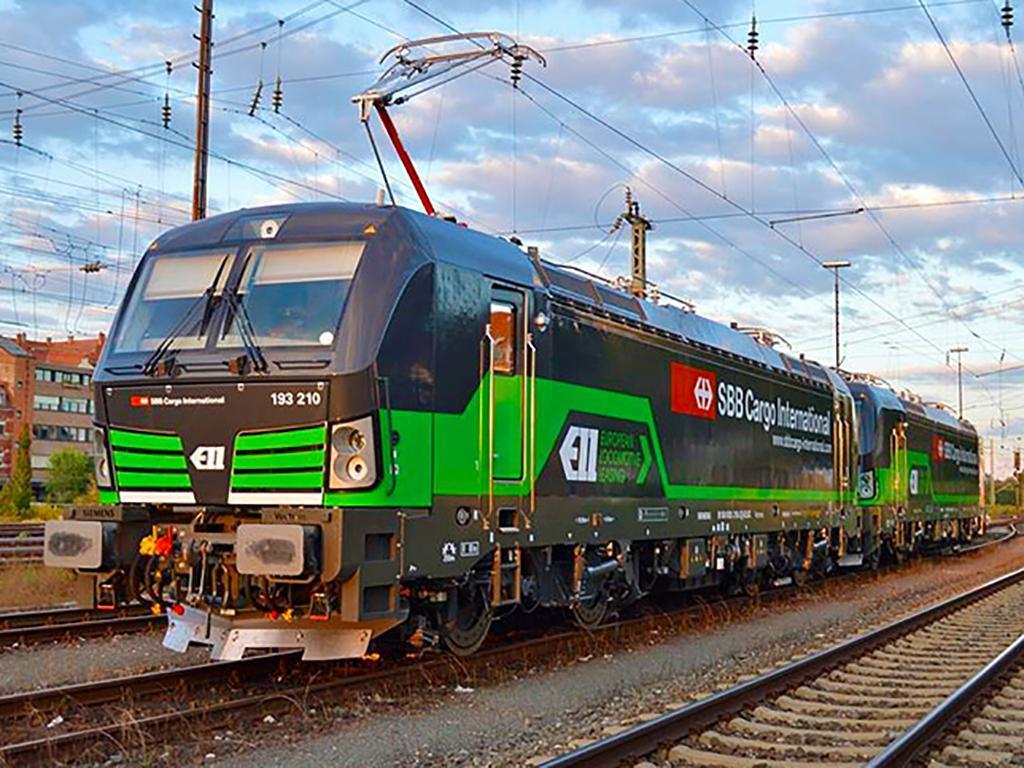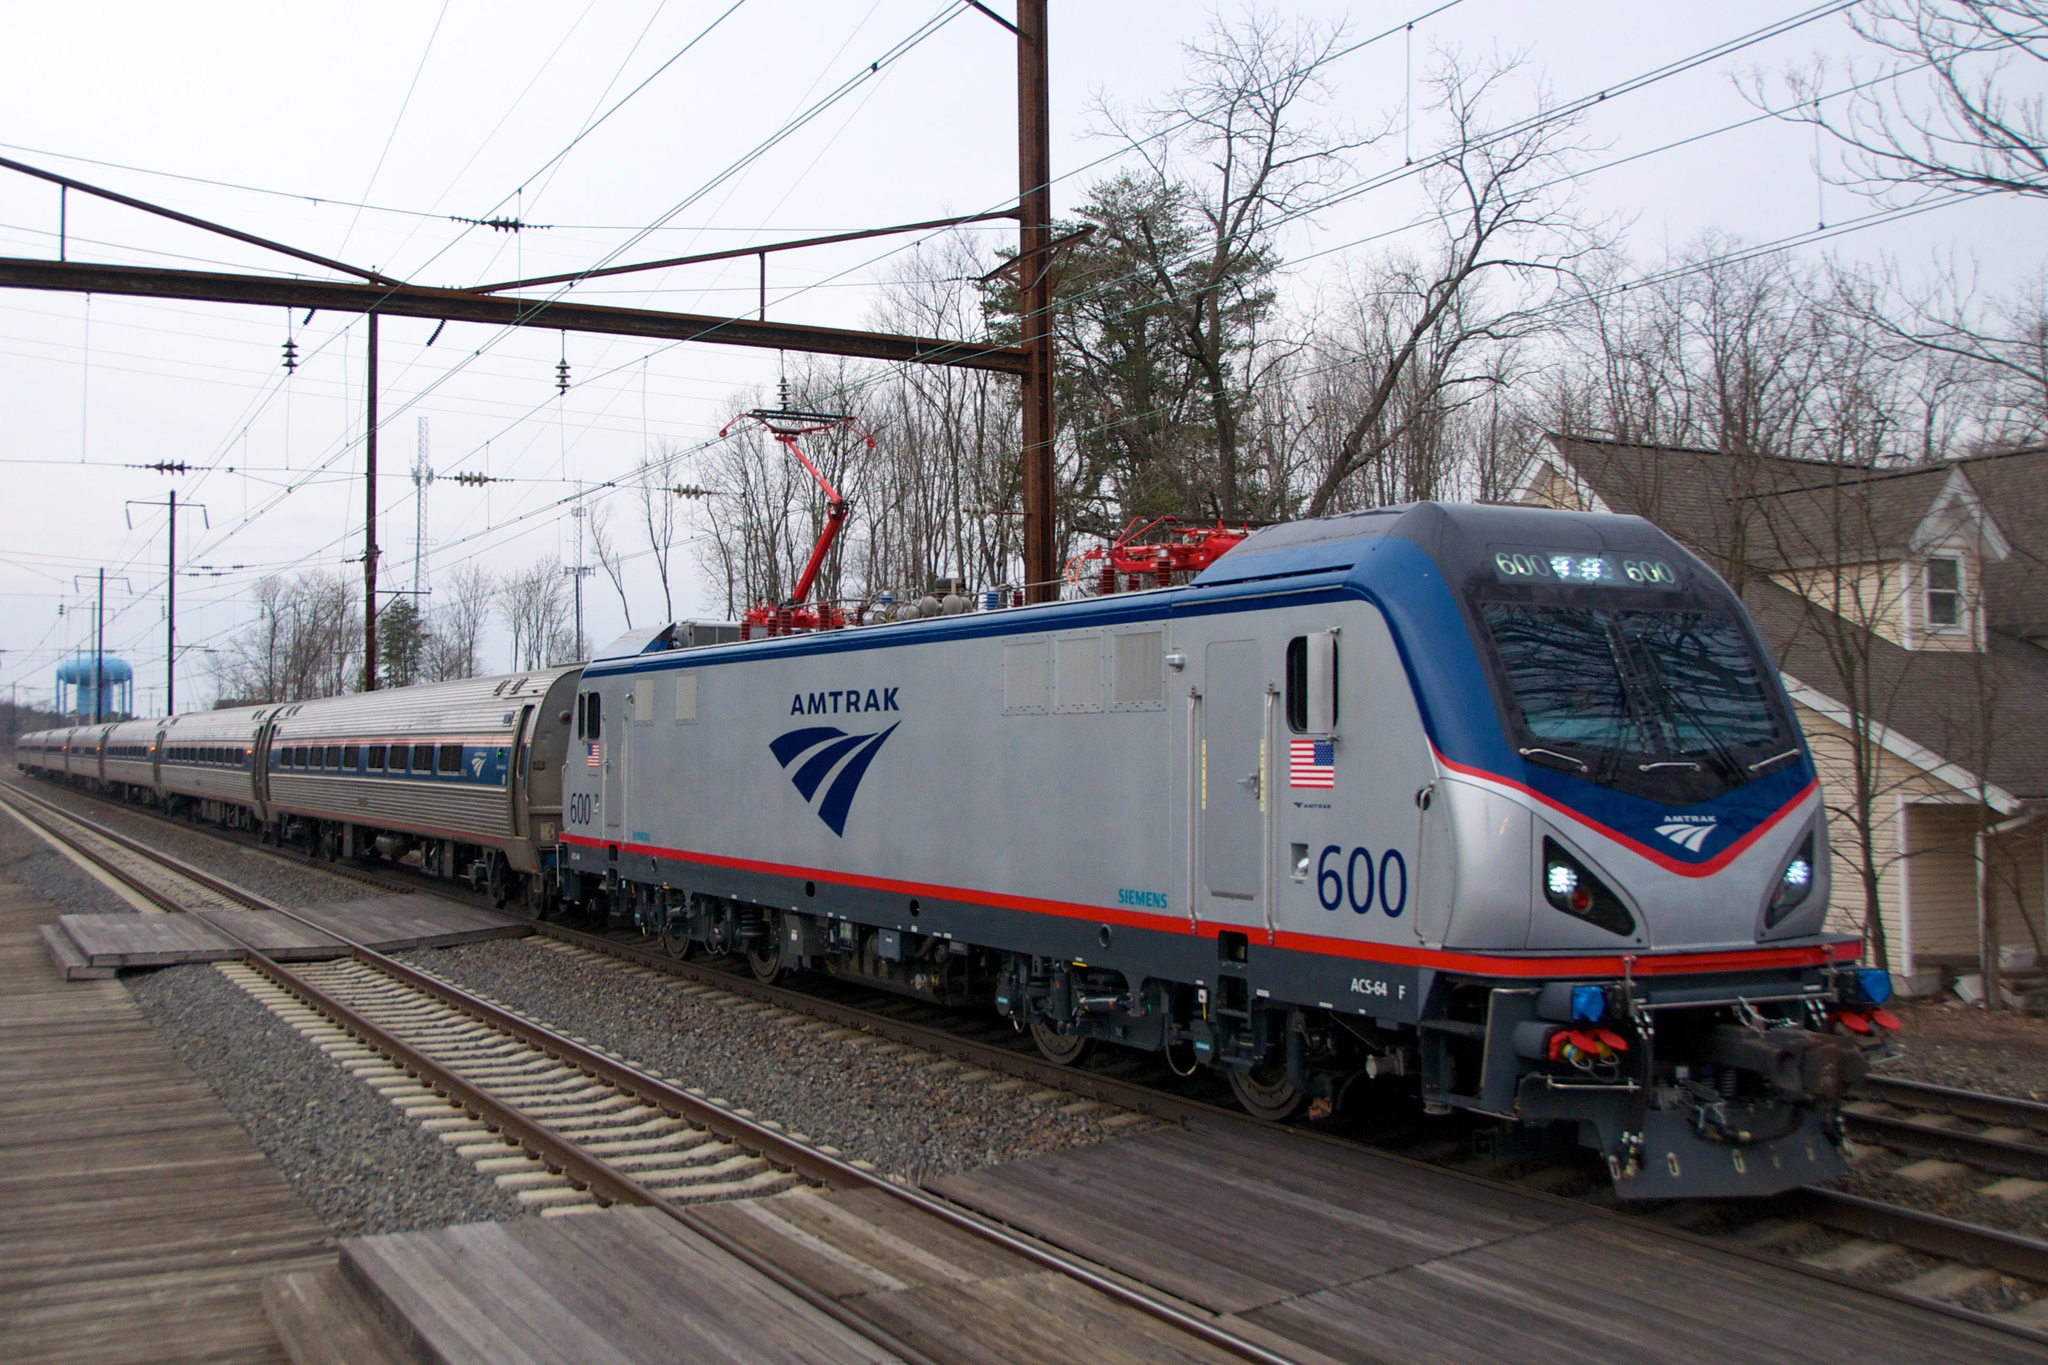The first image is the image on the left, the second image is the image on the right. Assess this claim about the two images: "The train in the image on the right has a single windshield.". Correct or not? Answer yes or no. Yes. The first image is the image on the left, the second image is the image on the right. Considering the images on both sides, is "A train is on a track next to bare-branched trees and a house with a peaked roof in one image." valid? Answer yes or no. Yes. 